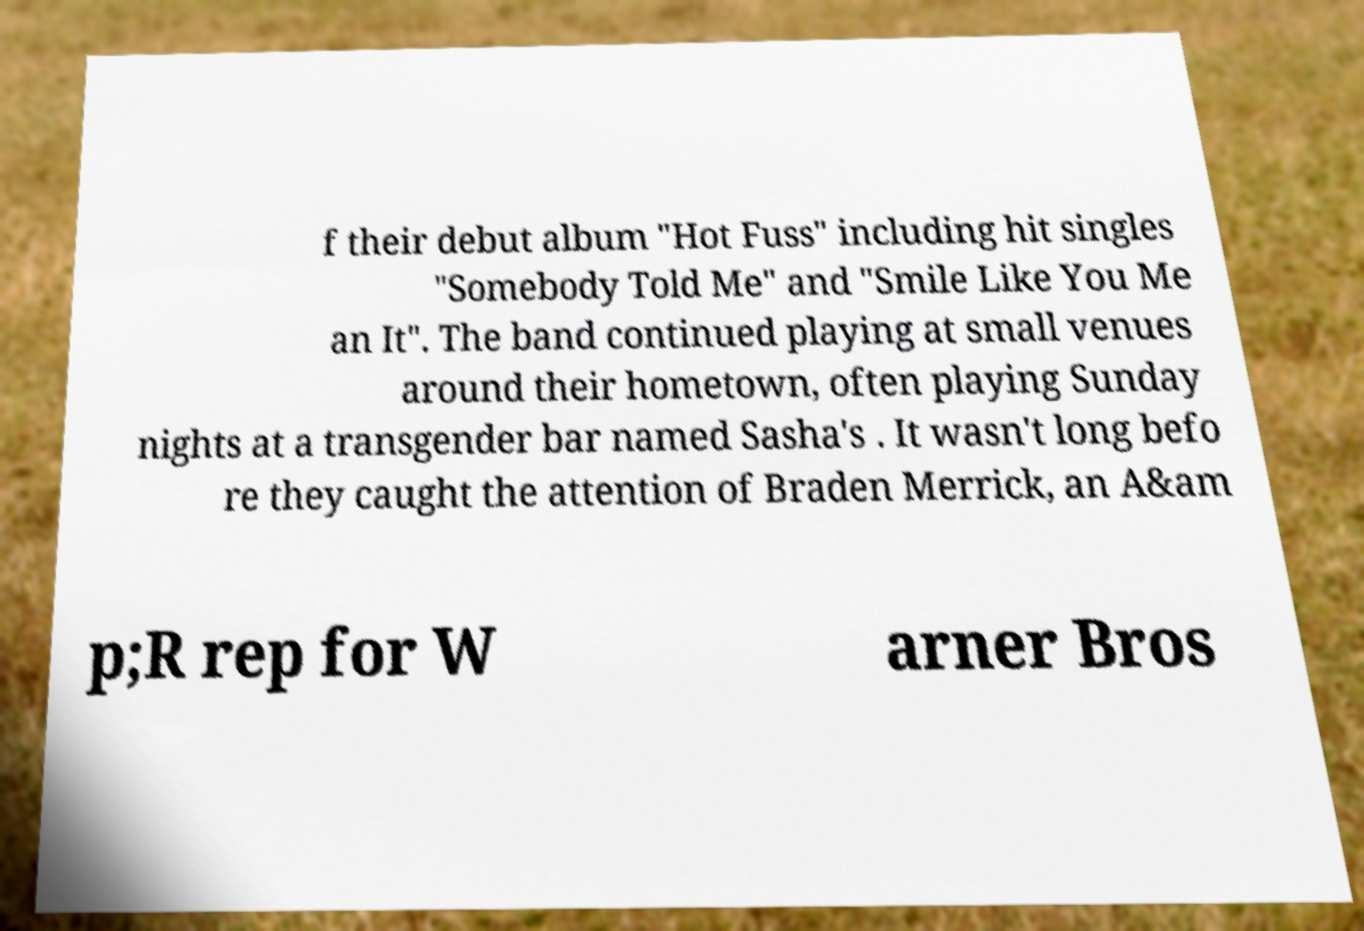Could you assist in decoding the text presented in this image and type it out clearly? f their debut album "Hot Fuss" including hit singles "Somebody Told Me" and "Smile Like You Me an It". The band continued playing at small venues around their hometown, often playing Sunday nights at a transgender bar named Sasha's . It wasn't long befo re they caught the attention of Braden Merrick, an A&am p;R rep for W arner Bros 